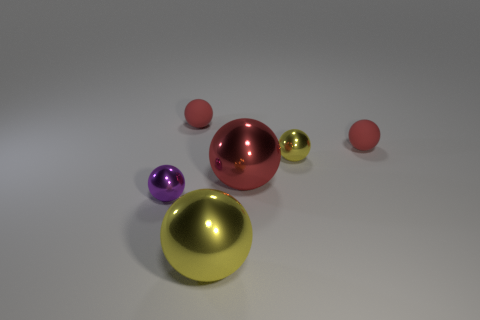How many other objects are there of the same shape as the big red object?
Provide a succinct answer. 5. Are there an equal number of small purple spheres in front of the red shiny object and balls that are on the right side of the tiny purple ball?
Keep it short and to the point. No. Is the material of the red object left of the large red sphere the same as the yellow object to the left of the tiny yellow thing?
Make the answer very short. No. What number of other things are the same size as the red shiny sphere?
Provide a short and direct response. 1. How many objects are either large yellow objects or yellow balls that are in front of the small yellow metal sphere?
Ensure brevity in your answer.  1. Are there an equal number of tiny things that are behind the small purple shiny ball and red balls?
Your answer should be very brief. Yes. What is the shape of the red thing that is the same material as the purple sphere?
Your response must be concise. Sphere. How many metallic objects are either purple cylinders or big balls?
Your response must be concise. 2. How many tiny red things are in front of the matte sphere that is to the left of the big yellow metal ball?
Ensure brevity in your answer.  1. How many tiny red balls are made of the same material as the small purple thing?
Keep it short and to the point. 0. 